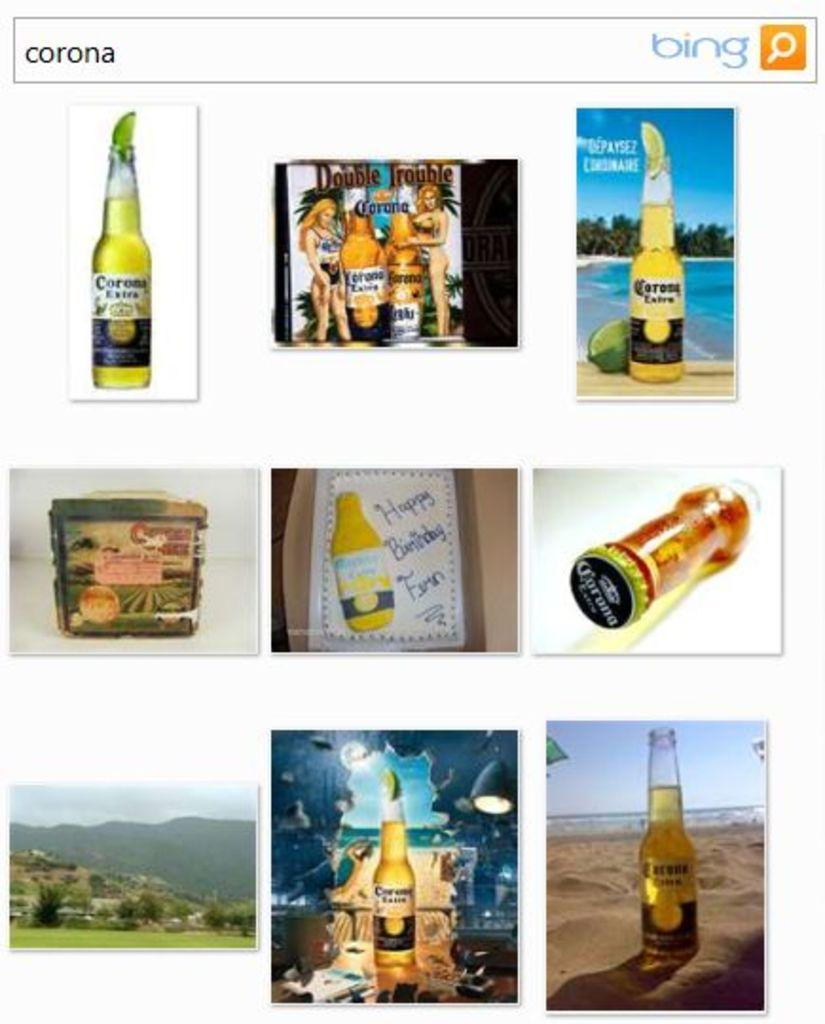<image>
Summarize the visual content of the image. Bing search page that has the text Corona on the search menu. 